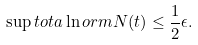Convert formula to latex. <formula><loc_0><loc_0><loc_500><loc_500>\sup t o t a \ln o r m { N } ( t ) & \leq \frac { 1 } { 2 } \epsilon .</formula> 